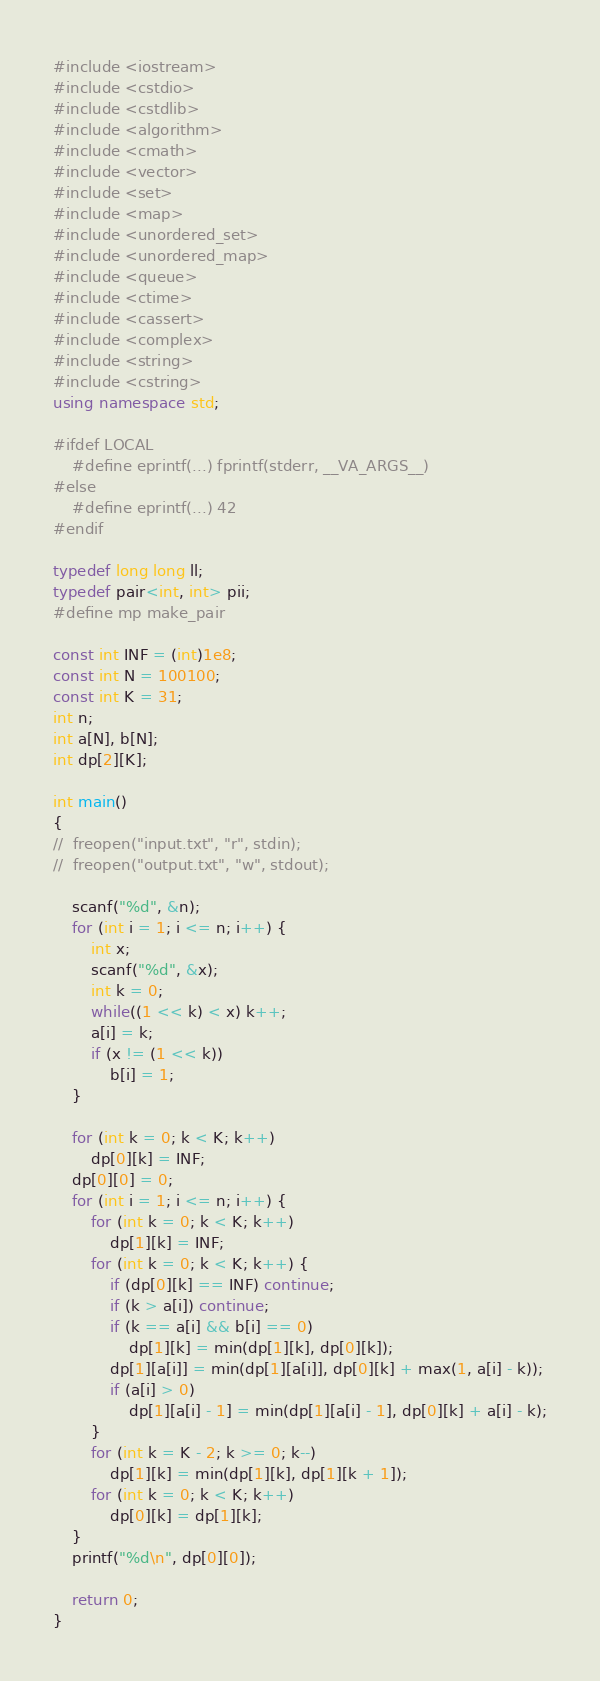Convert code to text. <code><loc_0><loc_0><loc_500><loc_500><_C++_>#include <iostream>
#include <cstdio>
#include <cstdlib>
#include <algorithm>
#include <cmath>
#include <vector>
#include <set>
#include <map>
#include <unordered_set>
#include <unordered_map>
#include <queue>
#include <ctime>
#include <cassert>
#include <complex>
#include <string>
#include <cstring>
using namespace std;

#ifdef LOCAL
	#define eprintf(...) fprintf(stderr, __VA_ARGS__)
#else
	#define eprintf(...) 42
#endif

typedef long long ll;
typedef pair<int, int> pii;
#define mp make_pair

const int INF = (int)1e8;
const int N = 100100;
const int K = 31;
int n;
int a[N], b[N];
int dp[2][K];

int main()
{
//	freopen("input.txt", "r", stdin);
//	freopen("output.txt", "w", stdout);

	scanf("%d", &n);
	for (int i = 1; i <= n; i++) {
		int x;
		scanf("%d", &x);
		int k = 0;
		while((1 << k) < x) k++;
		a[i] = k;
		if (x != (1 << k))
			b[i] = 1;
	}

	for (int k = 0; k < K; k++)
		dp[0][k] = INF;
	dp[0][0] = 0;
	for (int i = 1; i <= n; i++) {
		for (int k = 0; k < K; k++)
			dp[1][k] = INF;
		for (int k = 0; k < K; k++) {
			if (dp[0][k] == INF) continue;
			if (k > a[i]) continue;
			if (k == a[i] && b[i] == 0)
				dp[1][k] = min(dp[1][k], dp[0][k]);
			dp[1][a[i]] = min(dp[1][a[i]], dp[0][k] + max(1, a[i] - k));
			if (a[i] > 0)
				dp[1][a[i] - 1] = min(dp[1][a[i] - 1], dp[0][k] + a[i] - k);
		}
		for (int k = K - 2; k >= 0; k--)
			dp[1][k] = min(dp[1][k], dp[1][k + 1]);
		for (int k = 0; k < K; k++)
			dp[0][k] = dp[1][k];
	}
	printf("%d\n", dp[0][0]);

	return 0;
}
</code> 